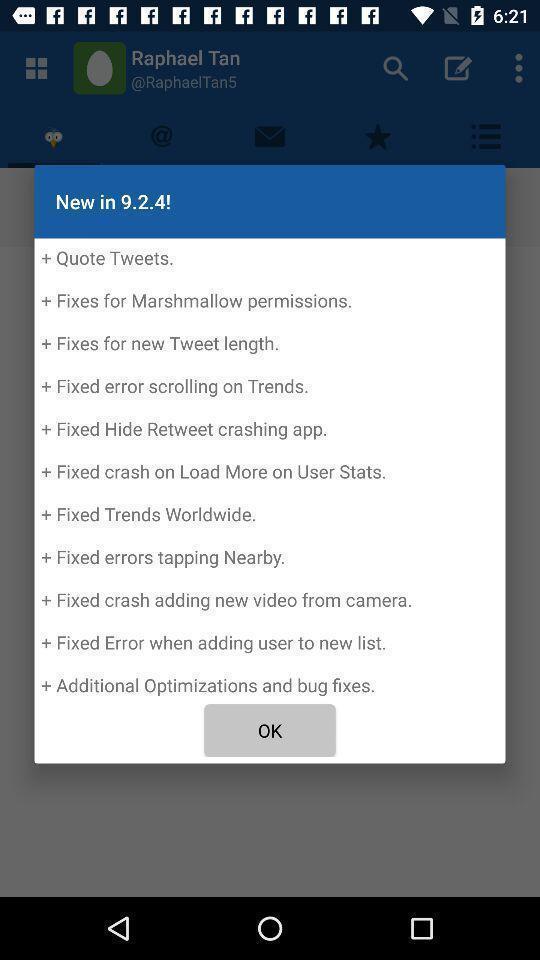Provide a textual representation of this image. Pop-up displaying information about an application. 